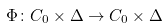Convert formula to latex. <formula><loc_0><loc_0><loc_500><loc_500>\Phi \colon C _ { 0 } \times \Delta \rightarrow C _ { 0 } \times \Delta</formula> 